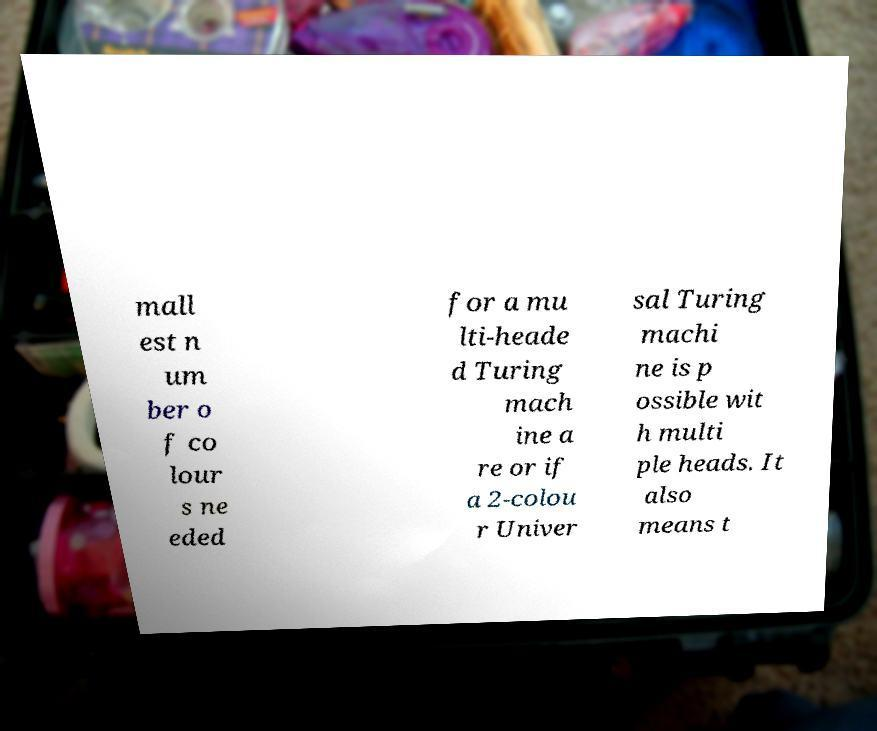Please read and relay the text visible in this image. What does it say? mall est n um ber o f co lour s ne eded for a mu lti-heade d Turing mach ine a re or if a 2-colou r Univer sal Turing machi ne is p ossible wit h multi ple heads. It also means t 